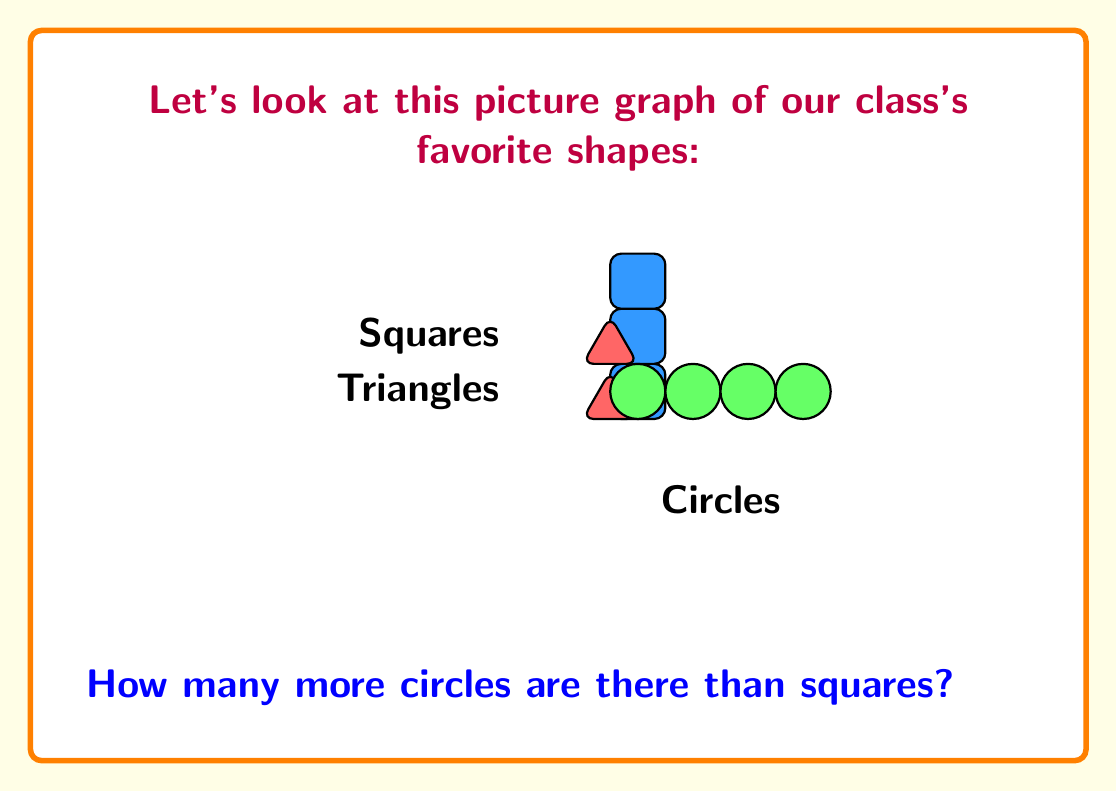Teach me how to tackle this problem. Let's count the shapes step by step:

1. Count the squares:
   There are 3 blue squares.

2. Count the circles:
   There are 4 green circles.

3. Calculate the difference:
   To find how many more circles there are than squares, we subtract:
   $$ \text{Circles} - \text{Squares} = 4 - 3 = 1 $$

So, there is 1 more circle than square in the picture graph.

This simple subtraction helps children practice comparing quantities and understanding the concept of "more than" using familiar shapes.
Answer: 1 